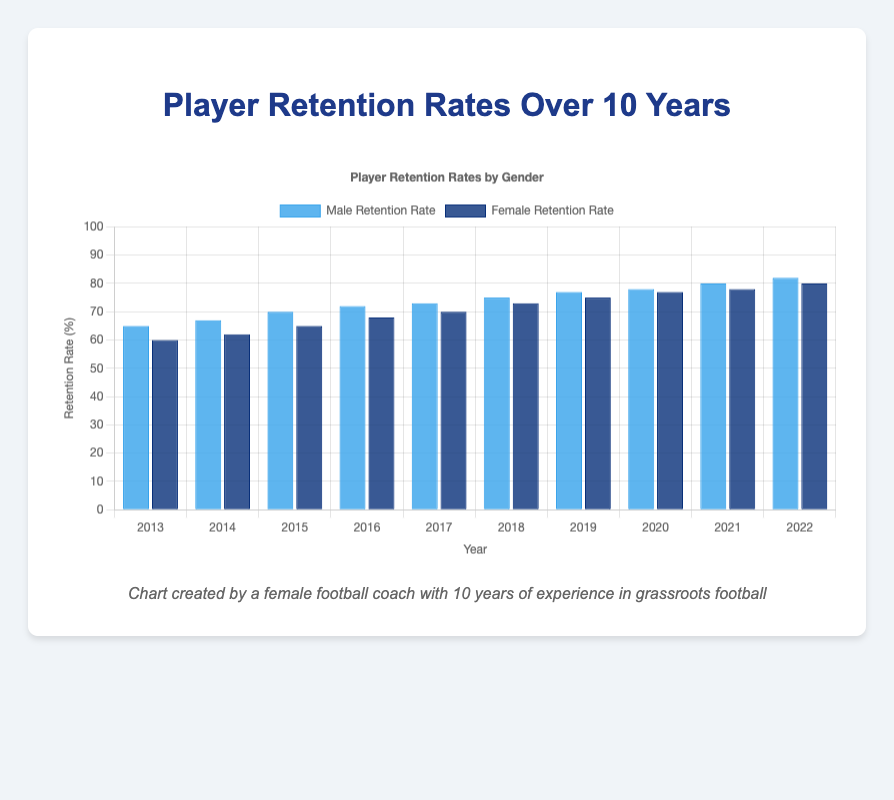What year had the lowest male retention rate? To find the year with the lowest male retention rate, look at the dataset and identify the year with the smallest value in the "MaleRetentionRate" column. The year 2013 has the lowest male retention rate of 65%
Answer: 2013 Which gender had a higher retention rate in 2015? Compare the retention rates for males and females in 2015 from the dataset. Male retention rate is 70%, and female retention rate is 65% in 2015.
Answer: Male What's the difference between male and female retention rates in 2018? Subtract the female retention rate from the male retention rate for the year 2018. The male retention rate is 75%, and the female retention rate is 73%, so the difference is 75% - 73% = 2%
Answer: 2% How did the female retention rate change from 2014 to 2022? Calculate the difference in female retention rates between 2014 and 2022. The rate in 2014 is 62%, and in 2022 it is 80%, so the change is 80% - 62% = 18%
Answer: Increased by 18% In which year did both male and female retention rates reach 70% or more? Identify the first year from the dataset where both retention rates are 70% or more. The year 2017 is the first when male retention rate is 73% and female retention rate is 70%
Answer: 2017 What is the average male retention rate over the 10 years? Calculate the mean of the male retention rates by summing them up and dividing by the number of years: (65 + 67 + 70 + 72 + 73 + 75 + 77 + 78 + 80 + 82) / 10 = 73.9%
Answer: 73.9% Between 2013 and 2017, in which year was the gap between male and female retention rates the smallest? Calculate the gap for each year between 2013 and 2017: 2013: 5%, 2014: 5%, 2015: 5%, 2016: 4%, 2017: 3%. The smallest gap is in 2017 with a 3% difference
Answer: 2017 Which gender showed a steeper increase in retention rates from 2013 to 2022? Compare the total increase in retention rates from 2013 to 2022 for both genders. Male: 82% - 65% = 17%, Female: 80% - 60% = 20%. Females had a steeper increase of 20% compared to 17% for males
Answer: Female In 2020, what was the combined retention rate for both genders? Add the male and female retention rates for 2020: 78% + 77% = 155%
Answer: 155% 